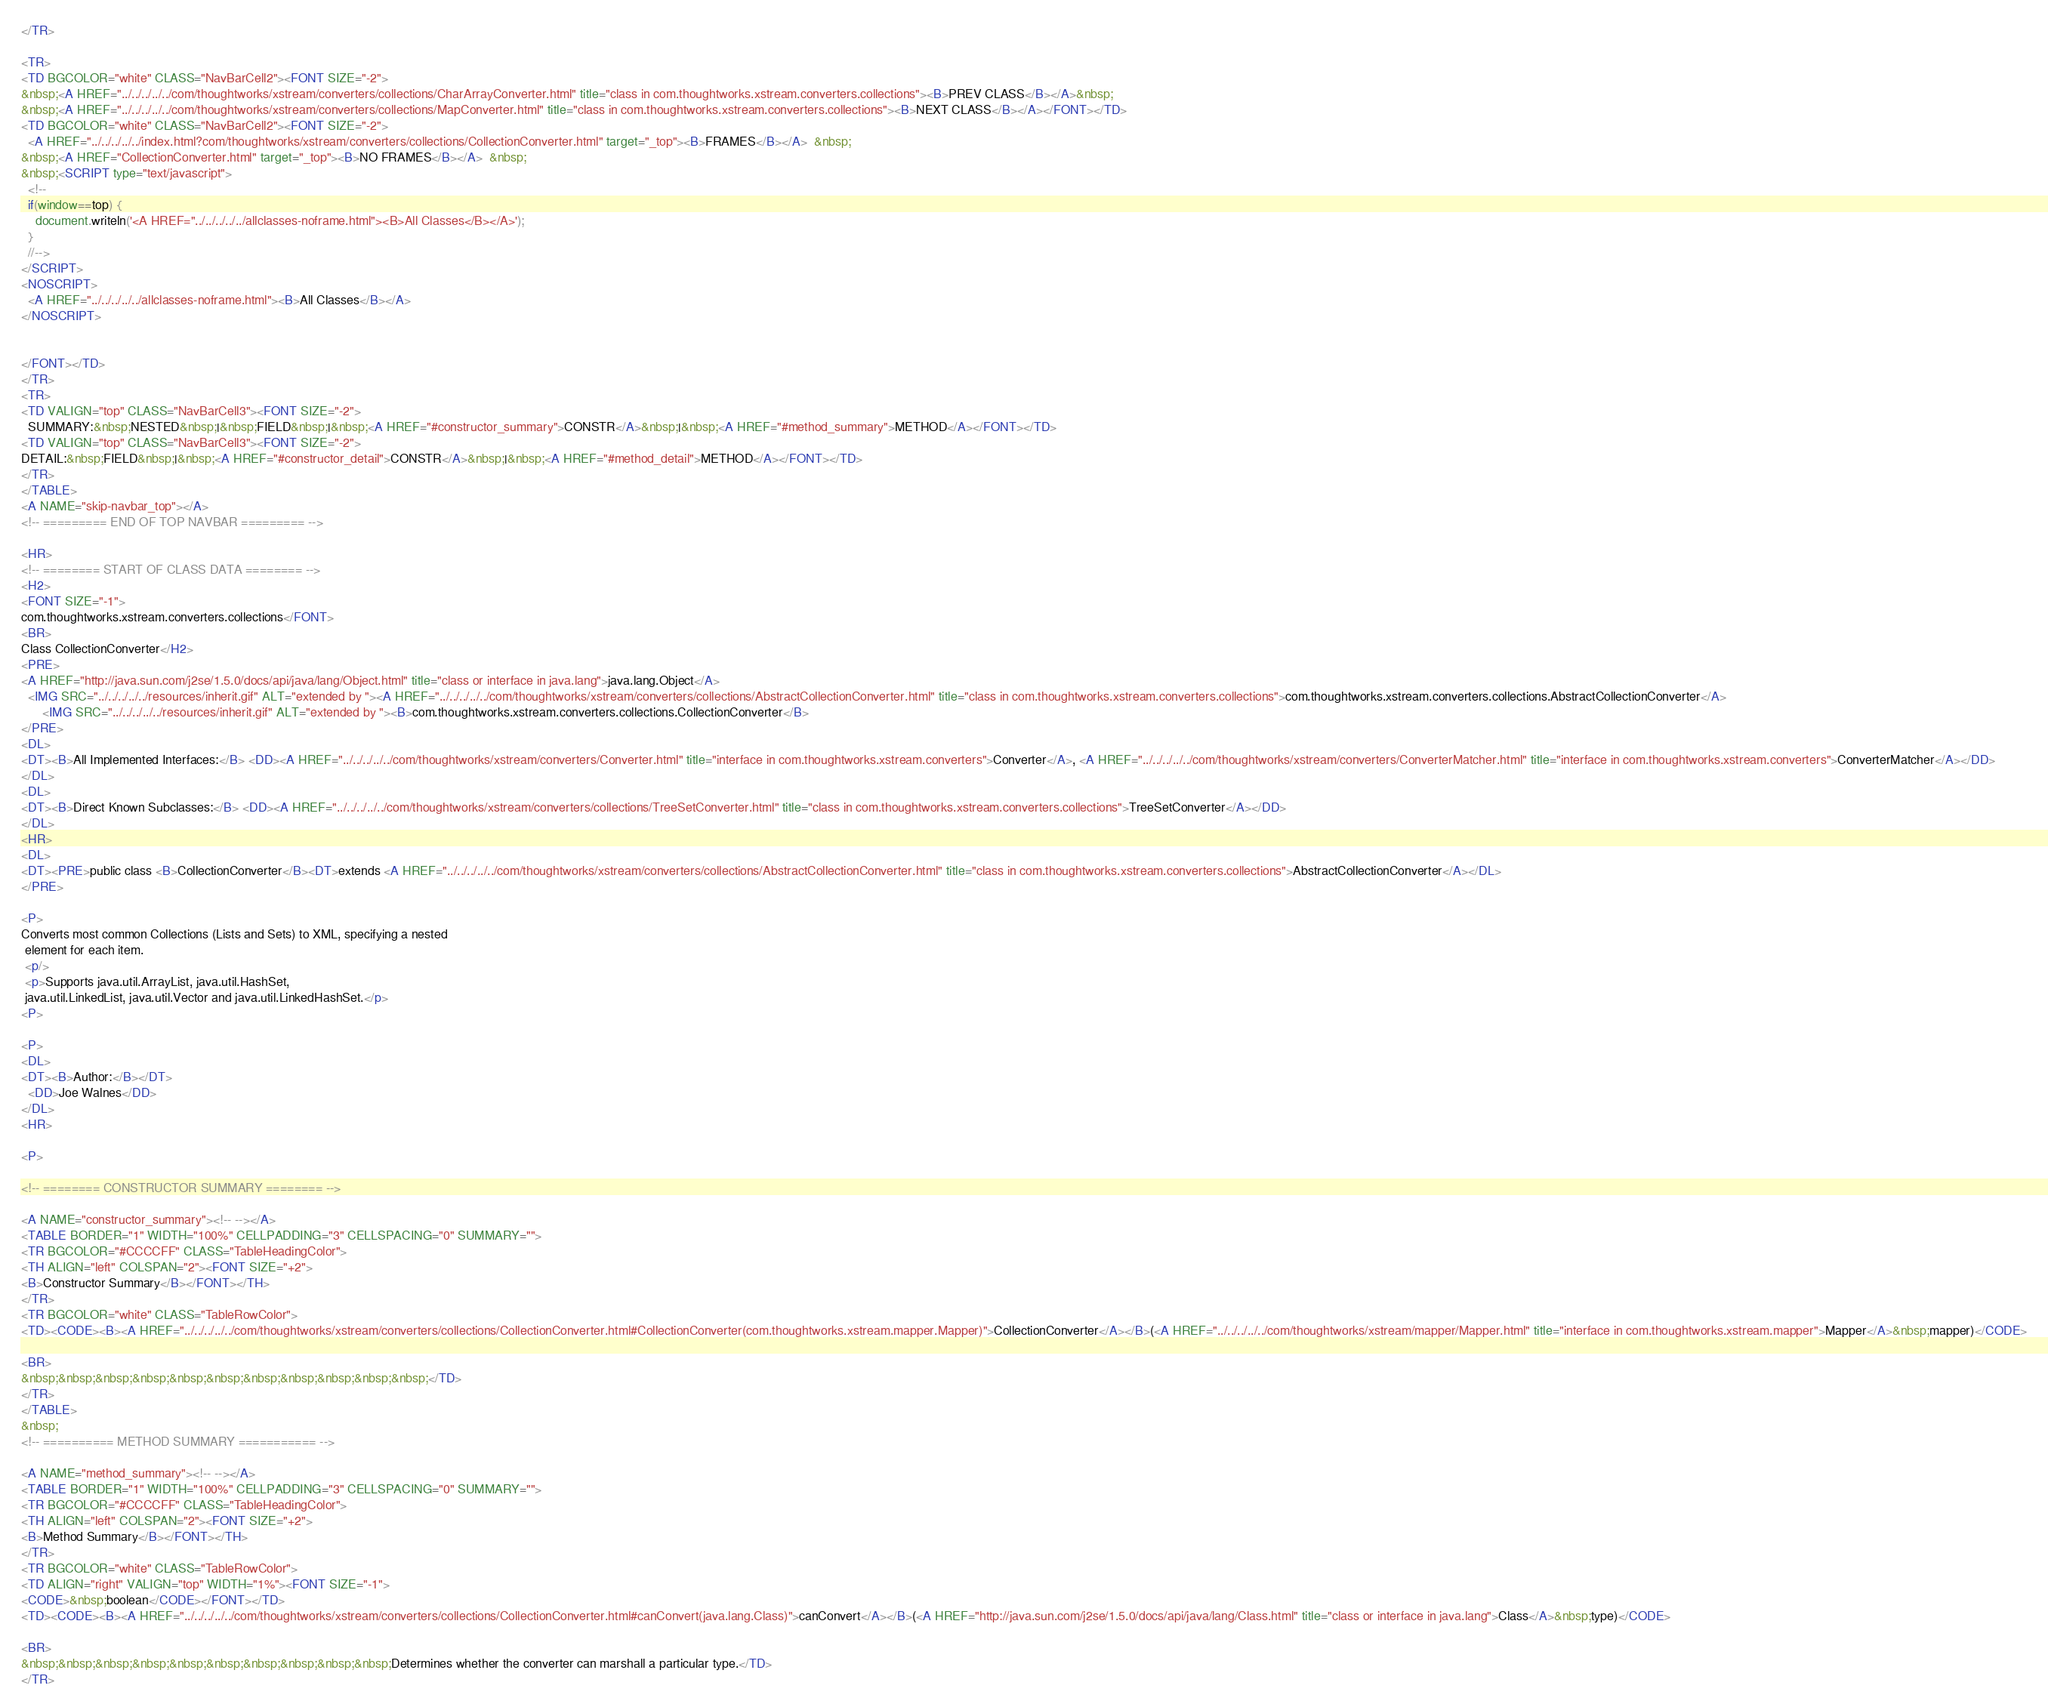<code> <loc_0><loc_0><loc_500><loc_500><_HTML_></TR>

<TR>
<TD BGCOLOR="white" CLASS="NavBarCell2"><FONT SIZE="-2">
&nbsp;<A HREF="../../../../../com/thoughtworks/xstream/converters/collections/CharArrayConverter.html" title="class in com.thoughtworks.xstream.converters.collections"><B>PREV CLASS</B></A>&nbsp;
&nbsp;<A HREF="../../../../../com/thoughtworks/xstream/converters/collections/MapConverter.html" title="class in com.thoughtworks.xstream.converters.collections"><B>NEXT CLASS</B></A></FONT></TD>
<TD BGCOLOR="white" CLASS="NavBarCell2"><FONT SIZE="-2">
  <A HREF="../../../../../index.html?com/thoughtworks/xstream/converters/collections/CollectionConverter.html" target="_top"><B>FRAMES</B></A>  &nbsp;
&nbsp;<A HREF="CollectionConverter.html" target="_top"><B>NO FRAMES</B></A>  &nbsp;
&nbsp;<SCRIPT type="text/javascript">
  <!--
  if(window==top) {
    document.writeln('<A HREF="../../../../../allclasses-noframe.html"><B>All Classes</B></A>');
  }
  //-->
</SCRIPT>
<NOSCRIPT>
  <A HREF="../../../../../allclasses-noframe.html"><B>All Classes</B></A>
</NOSCRIPT>


</FONT></TD>
</TR>
<TR>
<TD VALIGN="top" CLASS="NavBarCell3"><FONT SIZE="-2">
  SUMMARY:&nbsp;NESTED&nbsp;|&nbsp;FIELD&nbsp;|&nbsp;<A HREF="#constructor_summary">CONSTR</A>&nbsp;|&nbsp;<A HREF="#method_summary">METHOD</A></FONT></TD>
<TD VALIGN="top" CLASS="NavBarCell3"><FONT SIZE="-2">
DETAIL:&nbsp;FIELD&nbsp;|&nbsp;<A HREF="#constructor_detail">CONSTR</A>&nbsp;|&nbsp;<A HREF="#method_detail">METHOD</A></FONT></TD>
</TR>
</TABLE>
<A NAME="skip-navbar_top"></A>
<!-- ========= END OF TOP NAVBAR ========= -->

<HR>
<!-- ======== START OF CLASS DATA ======== -->
<H2>
<FONT SIZE="-1">
com.thoughtworks.xstream.converters.collections</FONT>
<BR>
Class CollectionConverter</H2>
<PRE>
<A HREF="http://java.sun.com/j2se/1.5.0/docs/api/java/lang/Object.html" title="class or interface in java.lang">java.lang.Object</A>
  <IMG SRC="../../../../../resources/inherit.gif" ALT="extended by "><A HREF="../../../../../com/thoughtworks/xstream/converters/collections/AbstractCollectionConverter.html" title="class in com.thoughtworks.xstream.converters.collections">com.thoughtworks.xstream.converters.collections.AbstractCollectionConverter</A>
      <IMG SRC="../../../../../resources/inherit.gif" ALT="extended by "><B>com.thoughtworks.xstream.converters.collections.CollectionConverter</B>
</PRE>
<DL>
<DT><B>All Implemented Interfaces:</B> <DD><A HREF="../../../../../com/thoughtworks/xstream/converters/Converter.html" title="interface in com.thoughtworks.xstream.converters">Converter</A>, <A HREF="../../../../../com/thoughtworks/xstream/converters/ConverterMatcher.html" title="interface in com.thoughtworks.xstream.converters">ConverterMatcher</A></DD>
</DL>
<DL>
<DT><B>Direct Known Subclasses:</B> <DD><A HREF="../../../../../com/thoughtworks/xstream/converters/collections/TreeSetConverter.html" title="class in com.thoughtworks.xstream.converters.collections">TreeSetConverter</A></DD>
</DL>
<HR>
<DL>
<DT><PRE>public class <B>CollectionConverter</B><DT>extends <A HREF="../../../../../com/thoughtworks/xstream/converters/collections/AbstractCollectionConverter.html" title="class in com.thoughtworks.xstream.converters.collections">AbstractCollectionConverter</A></DL>
</PRE>

<P>
Converts most common Collections (Lists and Sets) to XML, specifying a nested
 element for each item.
 <p/>
 <p>Supports java.util.ArrayList, java.util.HashSet,
 java.util.LinkedList, java.util.Vector and java.util.LinkedHashSet.</p>
<P>

<P>
<DL>
<DT><B>Author:</B></DT>
  <DD>Joe Walnes</DD>
</DL>
<HR>

<P>

<!-- ======== CONSTRUCTOR SUMMARY ======== -->

<A NAME="constructor_summary"><!-- --></A>
<TABLE BORDER="1" WIDTH="100%" CELLPADDING="3" CELLSPACING="0" SUMMARY="">
<TR BGCOLOR="#CCCCFF" CLASS="TableHeadingColor">
<TH ALIGN="left" COLSPAN="2"><FONT SIZE="+2">
<B>Constructor Summary</B></FONT></TH>
</TR>
<TR BGCOLOR="white" CLASS="TableRowColor">
<TD><CODE><B><A HREF="../../../../../com/thoughtworks/xstream/converters/collections/CollectionConverter.html#CollectionConverter(com.thoughtworks.xstream.mapper.Mapper)">CollectionConverter</A></B>(<A HREF="../../../../../com/thoughtworks/xstream/mapper/Mapper.html" title="interface in com.thoughtworks.xstream.mapper">Mapper</A>&nbsp;mapper)</CODE>

<BR>
&nbsp;&nbsp;&nbsp;&nbsp;&nbsp;&nbsp;&nbsp;&nbsp;&nbsp;&nbsp;&nbsp;</TD>
</TR>
</TABLE>
&nbsp;
<!-- ========== METHOD SUMMARY =========== -->

<A NAME="method_summary"><!-- --></A>
<TABLE BORDER="1" WIDTH="100%" CELLPADDING="3" CELLSPACING="0" SUMMARY="">
<TR BGCOLOR="#CCCCFF" CLASS="TableHeadingColor">
<TH ALIGN="left" COLSPAN="2"><FONT SIZE="+2">
<B>Method Summary</B></FONT></TH>
</TR>
<TR BGCOLOR="white" CLASS="TableRowColor">
<TD ALIGN="right" VALIGN="top" WIDTH="1%"><FONT SIZE="-1">
<CODE>&nbsp;boolean</CODE></FONT></TD>
<TD><CODE><B><A HREF="../../../../../com/thoughtworks/xstream/converters/collections/CollectionConverter.html#canConvert(java.lang.Class)">canConvert</A></B>(<A HREF="http://java.sun.com/j2se/1.5.0/docs/api/java/lang/Class.html" title="class or interface in java.lang">Class</A>&nbsp;type)</CODE>

<BR>
&nbsp;&nbsp;&nbsp;&nbsp;&nbsp;&nbsp;&nbsp;&nbsp;&nbsp;&nbsp;Determines whether the converter can marshall a particular type.</TD>
</TR></code> 